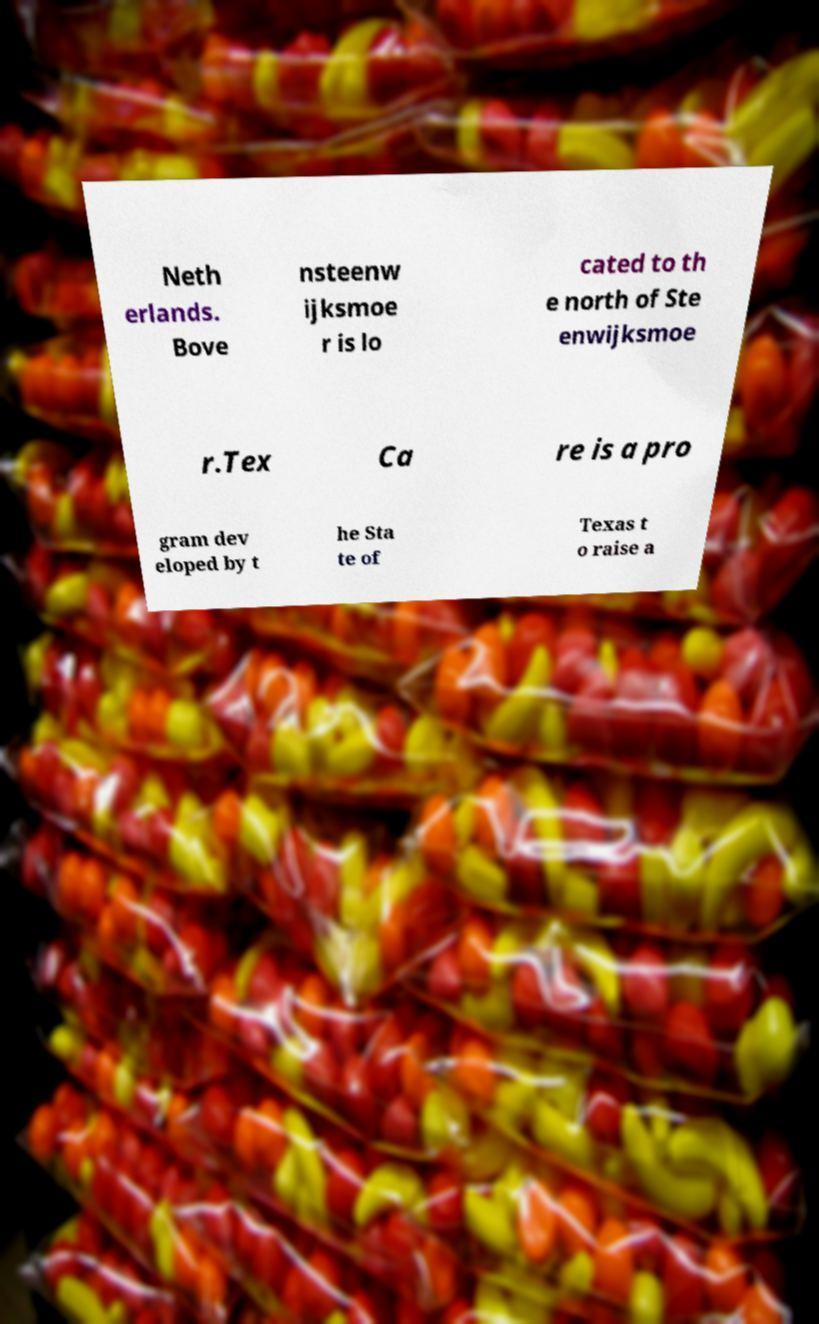Can you read and provide the text displayed in the image?This photo seems to have some interesting text. Can you extract and type it out for me? Neth erlands. Bove nsteenw ijksmoe r is lo cated to th e north of Ste enwijksmoe r.Tex Ca re is a pro gram dev eloped by t he Sta te of Texas t o raise a 